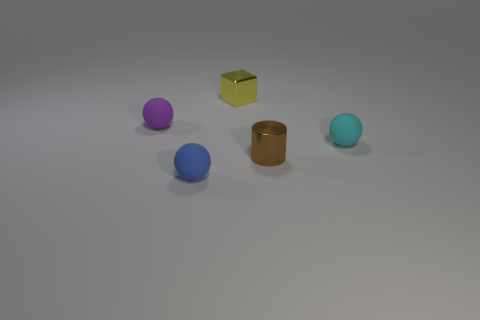There is a shiny object that is in front of the small thing to the left of the blue sphere; what is its size?
Your response must be concise. Small. There is a yellow block that is the same size as the blue matte ball; what material is it?
Your response must be concise. Metal. Are there any small cyan things made of the same material as the cylinder?
Ensure brevity in your answer.  No. What color is the tiny ball that is behind the small sphere to the right of the blue ball in front of the purple matte object?
Give a very brief answer. Purple. There is a small rubber thing that is on the right side of the small brown shiny cylinder; does it have the same color as the small rubber sphere left of the blue rubber ball?
Your answer should be compact. No. Are there any other things of the same color as the metal block?
Your response must be concise. No. Are there fewer metallic cylinders that are in front of the tiny brown object than yellow cylinders?
Offer a terse response. No. How many purple matte spheres are there?
Make the answer very short. 1. Do the purple matte object and the tiny rubber object that is right of the small blue sphere have the same shape?
Ensure brevity in your answer.  Yes. Is the number of tiny blue rubber balls to the left of the purple thing less than the number of tiny blue things in front of the blue object?
Keep it short and to the point. No. 